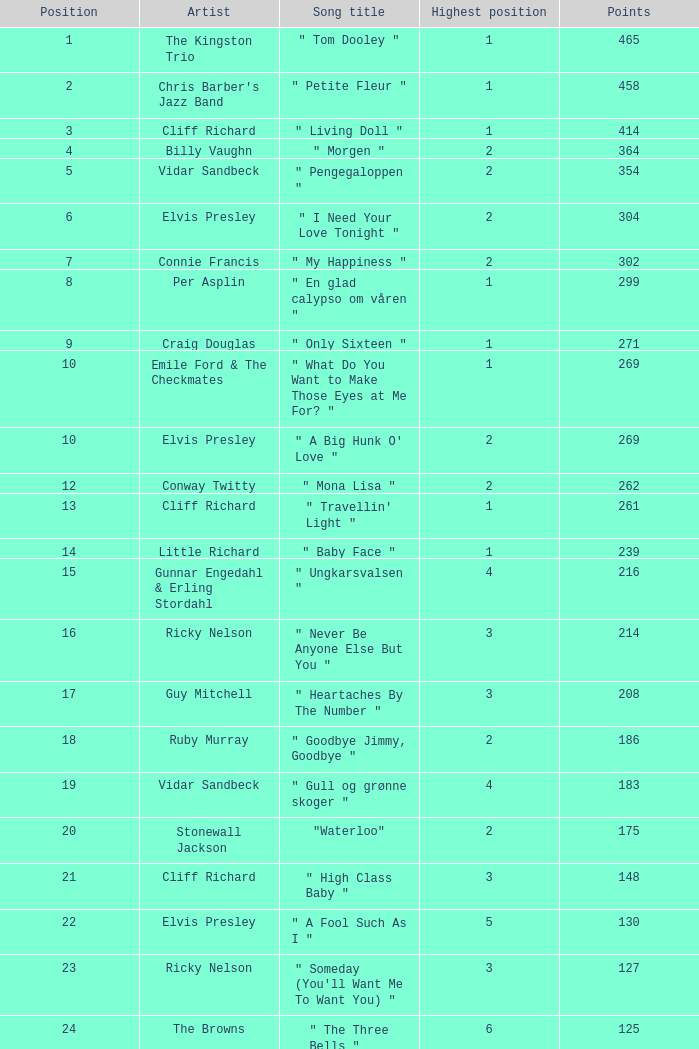Give me the full table as a dictionary. {'header': ['Position', 'Artist', 'Song title', 'Highest position', 'Points'], 'rows': [['1', 'The Kingston Trio', '" Tom Dooley "', '1', '465'], ['2', "Chris Barber's Jazz Band", '" Petite Fleur "', '1', '458'], ['3', 'Cliff Richard', '" Living Doll "', '1', '414'], ['4', 'Billy Vaughn', '" Morgen "', '2', '364'], ['5', 'Vidar Sandbeck', '" Pengegaloppen "', '2', '354'], ['6', 'Elvis Presley', '" I Need Your Love Tonight "', '2', '304'], ['7', 'Connie Francis', '" My Happiness "', '2', '302'], ['8', 'Per Asplin', '" En glad calypso om våren "', '1', '299'], ['9', 'Craig Douglas', '" Only Sixteen "', '1', '271'], ['10', 'Emile Ford & The Checkmates', '" What Do You Want to Make Those Eyes at Me For? "', '1', '269'], ['10', 'Elvis Presley', '" A Big Hunk O\' Love "', '2', '269'], ['12', 'Conway Twitty', '" Mona Lisa "', '2', '262'], ['13', 'Cliff Richard', '" Travellin\' Light "', '1', '261'], ['14', 'Little Richard', '" Baby Face "', '1', '239'], ['15', 'Gunnar Engedahl & Erling Stordahl', '" Ungkarsvalsen "', '4', '216'], ['16', 'Ricky Nelson', '" Never Be Anyone Else But You "', '3', '214'], ['17', 'Guy Mitchell', '" Heartaches By The Number "', '3', '208'], ['18', 'Ruby Murray', '" Goodbye Jimmy, Goodbye "', '2', '186'], ['19', 'Vidar Sandbeck', '" Gull og grønne skoger "', '4', '183'], ['20', 'Stonewall Jackson', '"Waterloo"', '2', '175'], ['21', 'Cliff Richard', '" High Class Baby "', '3', '148'], ['22', 'Elvis Presley', '" A Fool Such As I "', '5', '130'], ['23', 'Ricky Nelson', '" Someday (You\'ll Want Me To Want You) "', '3', '127'], ['24', 'The Browns', '" The Three Bells "', '6', '125'], ['25', 'Bruno Martino', '" Piove "', '8', '122'], ['26', 'Lloyd Price', '"Personality"', '6', '120'], ['27', 'Conway Twitty', '" It\'s Only Make Believe "', '2', '113'], ['28', 'Little Richard', '" By the Light of the Silvery Moon "', '4', '112'], ['29', 'Gunnar Engedahl & Erling Stordahl', '" Piken i dalen "', '5', '107'], ['30', 'Shirley Bassey', '" Kiss Me, Honey Honey, Kiss Me "', '6', '103'], ['31', 'Bobby Darin', '" Dream Lover "', '5', '100'], ['32', 'The Fleetwoods', '" Mr. Blue "', '5', '99'], ['33', 'Cliff Richard', '" Move It "', '5', '97'], ['33', 'Nora Brockstedt', '" Augustin "', '5', '97'], ['35', 'The Coasters', '" Charlie Brown "', '5', '85'], ['36', 'Cliff Richard', '" Never Mind "', '5', '82'], ['37', 'Jerry Keller', '" Here Comes Summer "', '8', '73'], ['38', 'Connie Francis', '" Lipstick On Your Collar "', '7', '80'], ['39', 'Lloyd Price', '" Stagger Lee "', '8', '58'], ['40', 'Floyd Robinson', '" Makin\' Love "', '7', '53'], ['41', 'Jane Morgan', '" The Day The Rains Came "', '7', '49'], ['42', 'Bing Crosby', '" White Christmas "', '6', '41'], ['43', 'Paul Anka', '" Lonely Boy "', '9', '36'], ['44', 'Bobby Darin', '" Mack The Knife "', '9', '34'], ['45', 'Pat Boone', '" I\'ll Remember Tonight "', '9', '23'], ['46', 'Sam Cooke', '" Only Sixteen "', '10', '22'], ['47', 'Bruno Martino', '" Come prima "', '9', '12']]} What is the nme of the song performed by billy vaughn? " Morgen ". 